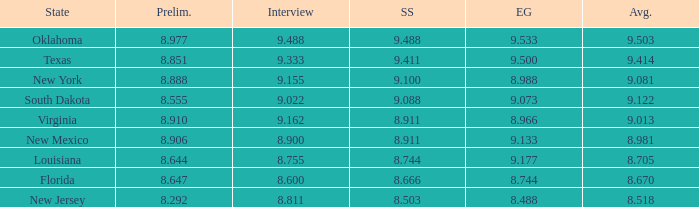What is the total number of average where evening gown is 8.988 1.0. 